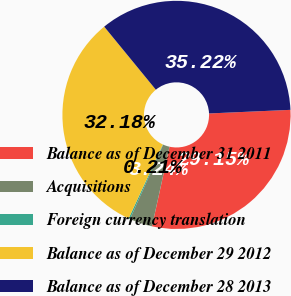Convert chart to OTSL. <chart><loc_0><loc_0><loc_500><loc_500><pie_chart><fcel>Balance as of December 31 2011<fcel>Acquisitions<fcel>Foreign currency translation<fcel>Balance as of December 29 2012<fcel>Balance as of December 28 2013<nl><fcel>29.15%<fcel>3.24%<fcel>0.21%<fcel>32.18%<fcel>35.22%<nl></chart> 